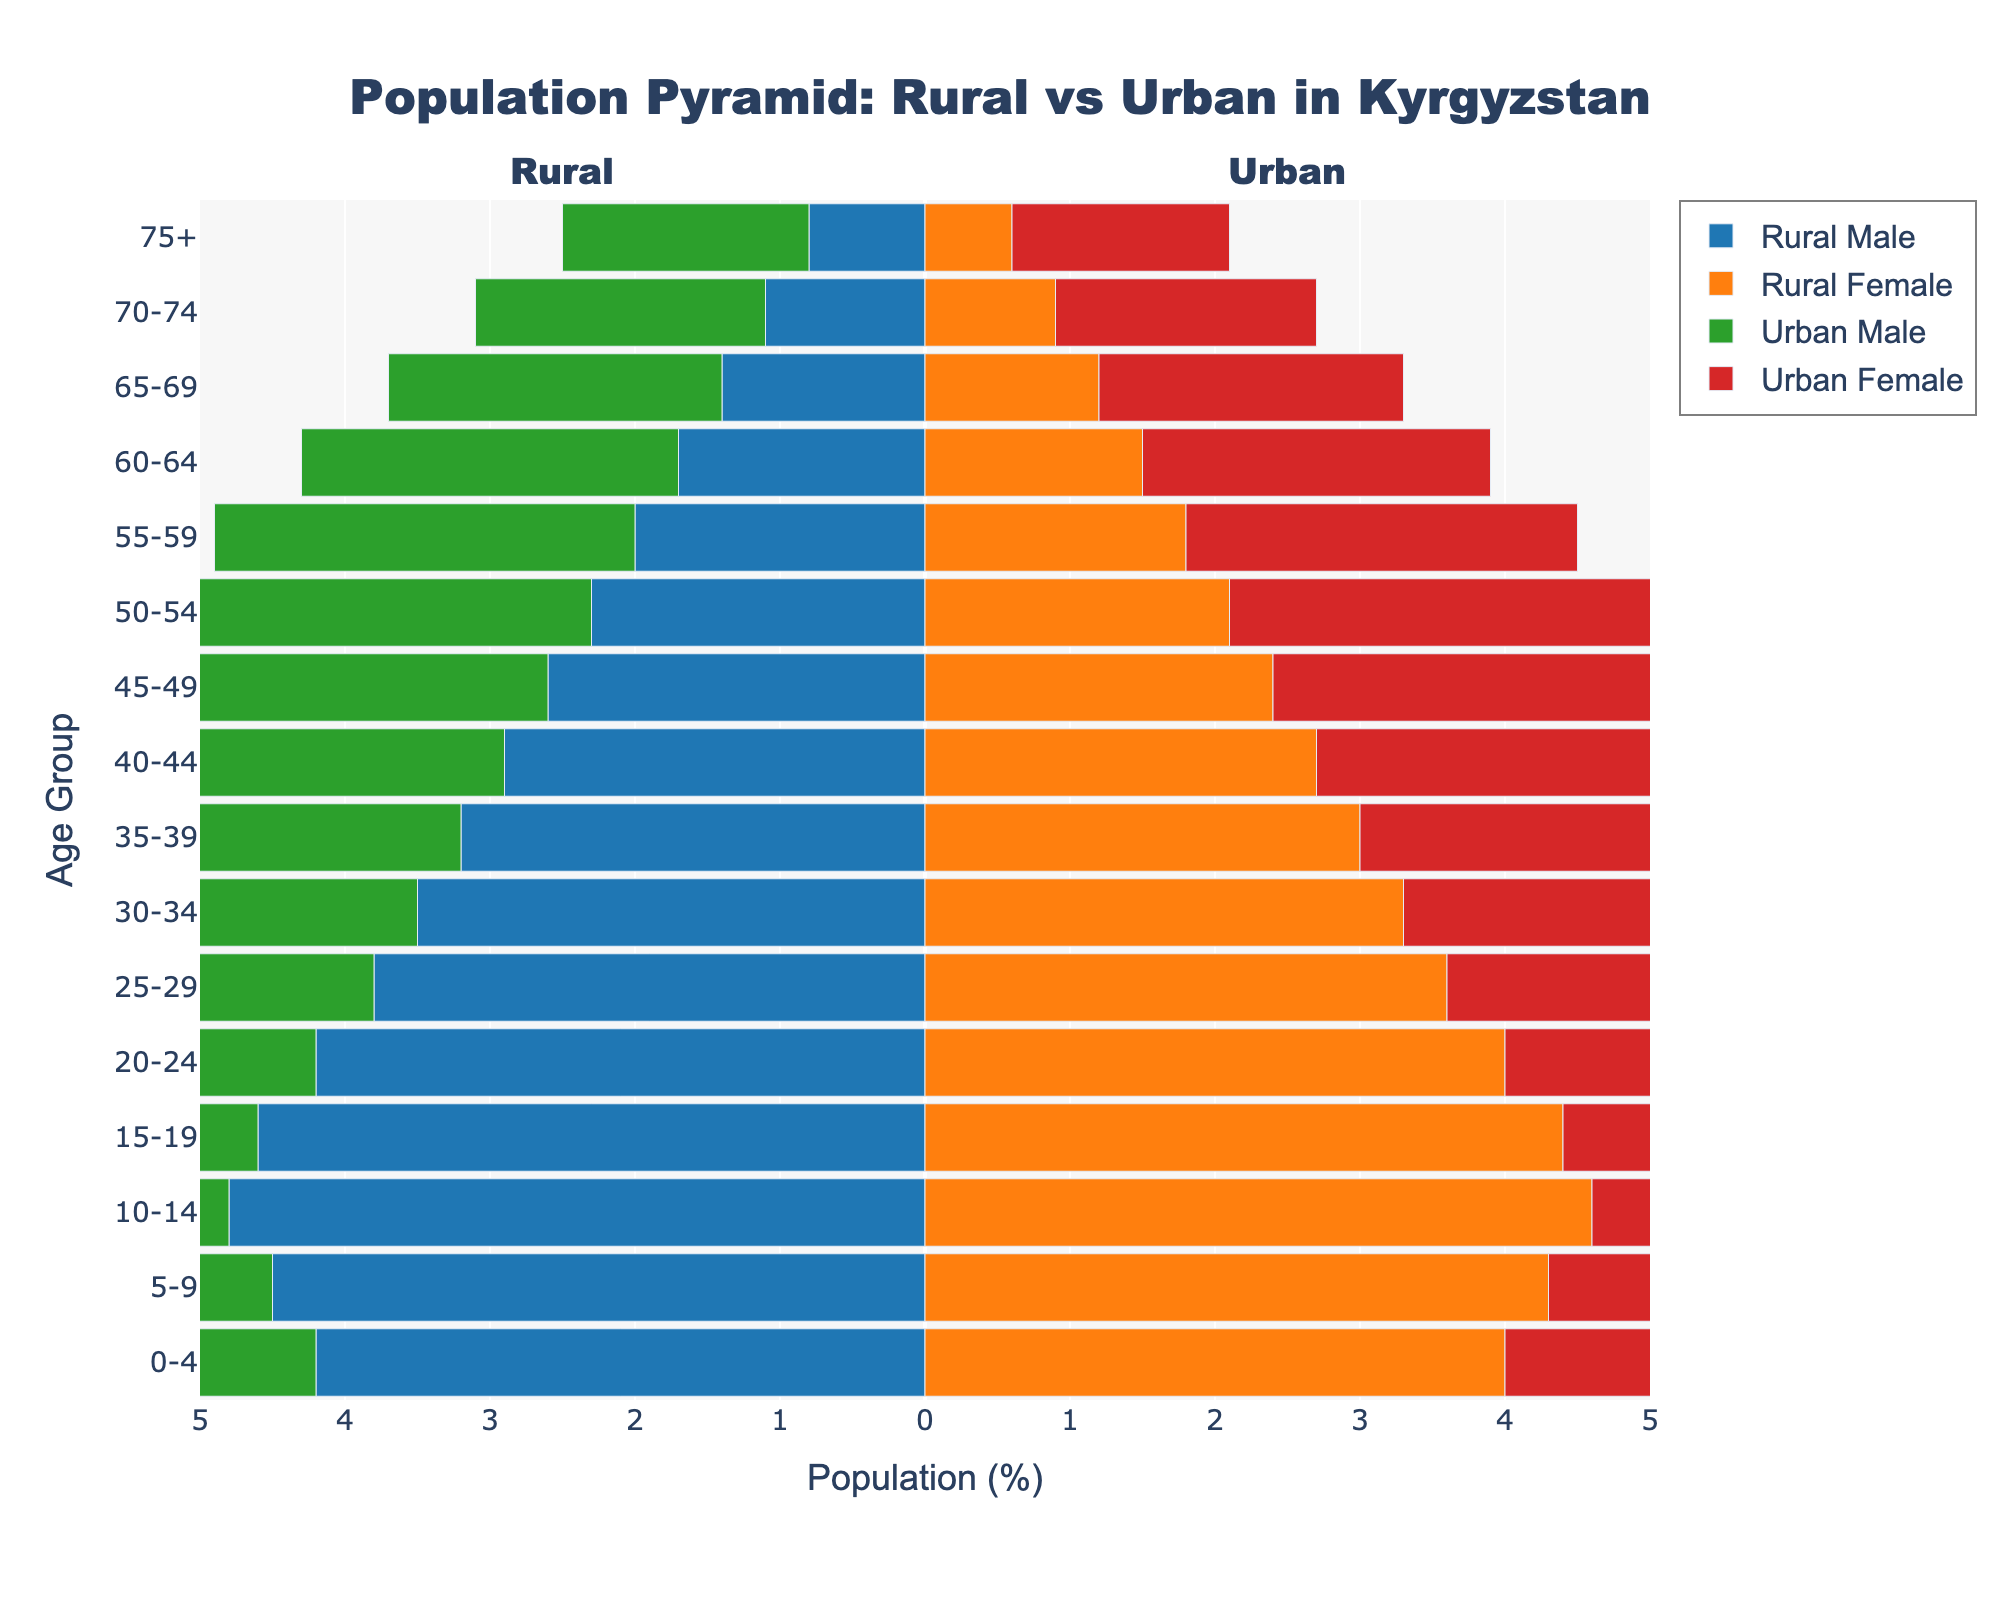What is the range of the x-axis? The x-axis in the figure represents the population percentage and ranges from -5% to 5%.
Answer: -5% to 5% Which demographic has the highest population percentage in the rural areas? The age group 10-14 has the highest population percentage in the rural areas, with 4.8% for males and 4.6% for females.
Answer: Age group 10-14 What is the gender that has a higher percentage in the age group 25-29 in urban areas? In urban areas for the age group 25-29, females have a higher percentage (4.6%) compared to males (4.4%).
Answer: Female How does the population percentage for rural males aged 0-4 compare to that for urban males in the same age group? The population percentage for rural males aged 0-4 is higher (4.2%) compared to urban males in the same age group (3.8%). Rural male 4.2%, Urban male 3.8%.
Answer: Rural males have a higher percentage Which population segment decreases more sharply after the age group 50-54: Rural or Urban? By observing the declining trend from age group 50-54 onwards, the rural population percentage decreases more sharply than the urban population. E.g., Rural male goes from 2.3% to 0.8%, whereas Urban male goes from 3.2% to 1.7% in the older age groups.
Answer: Rural decreases more sharply What is the percentage difference between urban males and urban females in the age group 20-24? Subtract the percentage of urban females (4.3%) from urban males (4.5%) for the age group 20-24. The difference is 4.5% - 4.3% = 0.2%.
Answer: 0.2% In the age group 65-69, compare the combined population of rural and urban males to that of females. Combined rural and urban males: (1.4% + 2.3%) = 3.7%. Combined rural and urban females: (1.2% + 2.1%) = 3.3%. Hence, males have a higher combined percentage.
Answer: Males have a higher combined percentage For what age groups do urban females have the highest percentage compared to other gender groups in the urban area? Urban females have the highest percentage among urban groups for the age groups 25-29 (4.4%), 30-34 (4.2%), and 35-39 (3.9%). No other gender group surpasses these values in their respective age groups.
Answer: Age groups 25-29, 30-34, 35-39 What trend can you observe in the population pyramid as age increases for both rural and urban areas? As age increases, both rural and urban areas show a decreasing trend in population percentage. Specifically, the percentage decreases rapidly after the age group 15-19.
Answer: Population percentage decreases 